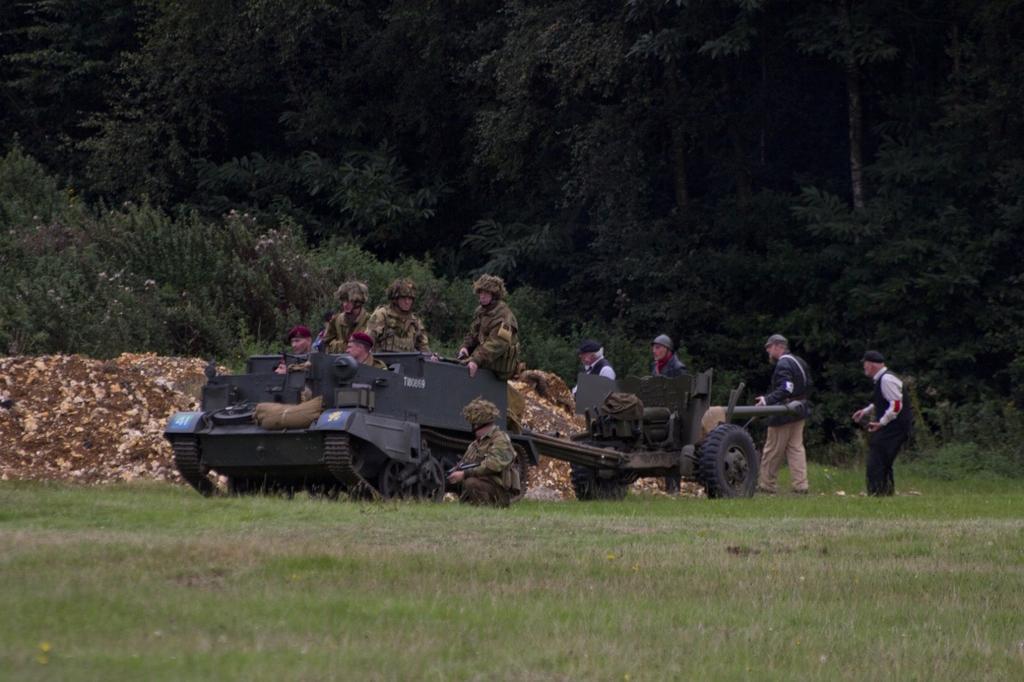Please provide a concise description of this image. In the image there are few people sat on panzer and behind it there is mini tanker. In the background there are trees,On floor there is grass. 